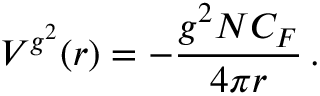Convert formula to latex. <formula><loc_0><loc_0><loc_500><loc_500>V ^ { g ^ { 2 } } ( r ) = - \frac { g ^ { 2 } N C _ { F } } { 4 \pi r } \, .</formula> 